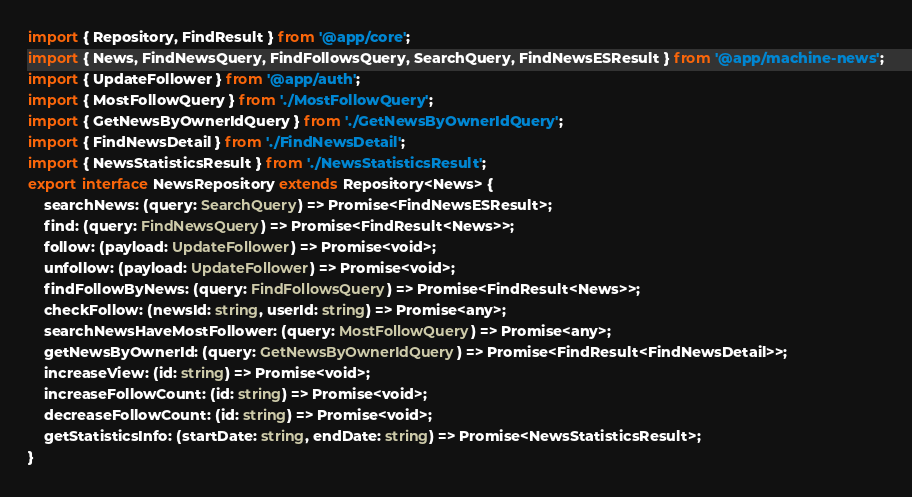<code> <loc_0><loc_0><loc_500><loc_500><_TypeScript_>import { Repository, FindResult } from '@app/core';
import { News, FindNewsQuery, FindFollowsQuery, SearchQuery, FindNewsESResult } from '@app/machine-news';
import { UpdateFollower } from '@app/auth';
import { MostFollowQuery } from './MostFollowQuery';
import { GetNewsByOwnerIdQuery } from './GetNewsByOwnerIdQuery';
import { FindNewsDetail } from './FindNewsDetail';
import { NewsStatisticsResult } from './NewsStatisticsResult';
export interface NewsRepository extends Repository<News> {
    searchNews: (query: SearchQuery) => Promise<FindNewsESResult>;
    find: (query: FindNewsQuery) => Promise<FindResult<News>>;
    follow: (payload: UpdateFollower) => Promise<void>;
    unfollow: (payload: UpdateFollower) => Promise<void>;
    findFollowByNews: (query: FindFollowsQuery) => Promise<FindResult<News>>;
    checkFollow: (newsId: string, userId: string) => Promise<any>;
    searchNewsHaveMostFollower: (query: MostFollowQuery) => Promise<any>;
    getNewsByOwnerId: (query: GetNewsByOwnerIdQuery) => Promise<FindResult<FindNewsDetail>>;
    increaseView: (id: string) => Promise<void>;
    increaseFollowCount: (id: string) => Promise<void>;
    decreaseFollowCount: (id: string) => Promise<void>;
    getStatisticsInfo: (startDate: string, endDate: string) => Promise<NewsStatisticsResult>;
}
</code> 